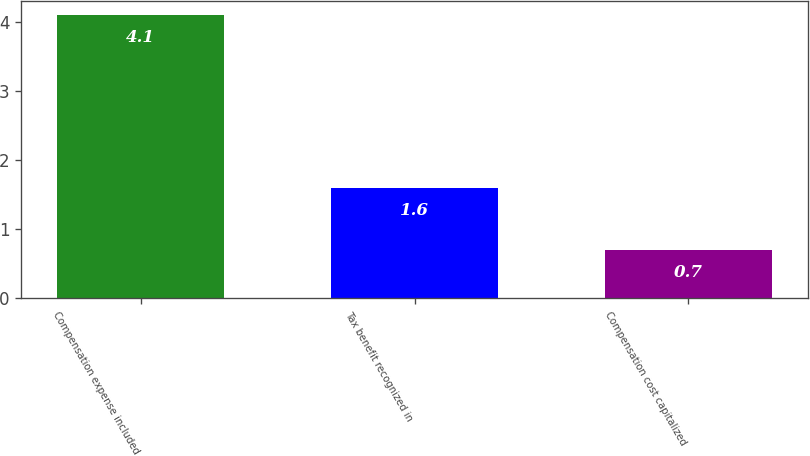<chart> <loc_0><loc_0><loc_500><loc_500><bar_chart><fcel>Compensation expense included<fcel>Tax benefit recognized in<fcel>Compensation cost capitalized<nl><fcel>4.1<fcel>1.6<fcel>0.7<nl></chart> 